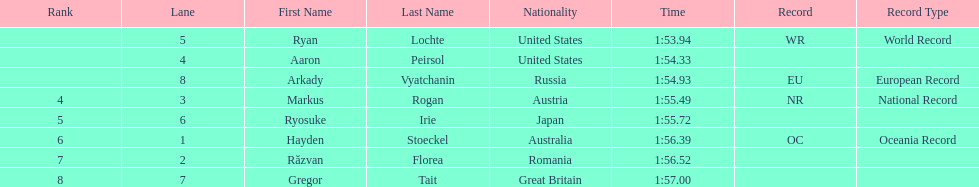Did austria or russia rank higher? Russia. Would you be able to parse every entry in this table? {'header': ['Rank', 'Lane', 'First Name', 'Last Name', 'Nationality', 'Time', 'Record', 'Record Type'], 'rows': [['', '5', 'Ryan', 'Lochte', 'United States', '1:53.94', 'WR', 'World Record'], ['', '4', 'Aaron', 'Peirsol', 'United States', '1:54.33', '', ''], ['', '8', 'Arkady', 'Vyatchanin', 'Russia', '1:54.93', 'EU', 'European Record'], ['4', '3', 'Markus', 'Rogan', 'Austria', '1:55.49', 'NR', 'National Record'], ['5', '6', 'Ryosuke', 'Irie', 'Japan', '1:55.72', '', ''], ['6', '1', 'Hayden', 'Stoeckel', 'Australia', '1:56.39', 'OC', 'Oceania Record'], ['7', '2', 'Răzvan', 'Florea', 'Romania', '1:56.52', '', ''], ['8', '7', 'Gregor', 'Tait', 'Great Britain', '1:57.00', '', '']]} 